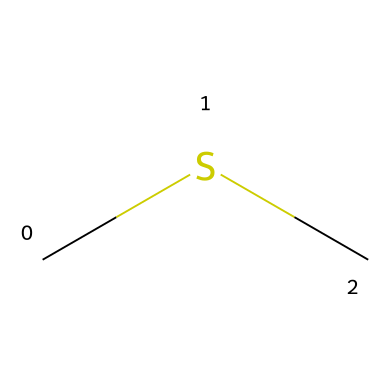What is the molecular formula of dimethyl sulfide? The SMILES representation "CSC" indicates there are two carbon (C) atoms and one sulfur (S) atom present. Thus, the molecular formula combines these elements, leading to the formula C2H6S, which also includes hydrogen atoms (H) necessary for bonding.
Answer: C2H6S How many carbon atoms are present in dimethyl sulfide? Analyzing the SMILES structure "CSC", we can see there are two distinct 'C's present in the sequence, which indicates the number of carbon atoms. Therefore, it is straightforward to count them directly from the structure.
Answer: 2 What type of chemical bond connects the carbon atoms to sulfur in dimethyl sulfide? In the structure represented by "CSC", the carbon atoms are connected through single bonds to each other and also to the sulfur atom. Sulfur typically forms single bonds with carbon in this compound type, so we deduce the bond type for clarity.
Answer: single bond How many hydrogen atoms are bonded to each carbon atom in dimethyl sulfide? Given the structure "CSC", each carbon atom must be bonded to enough hydrogen atoms to fulfill the tetravalency of carbon (which needs four bonds). Since one carbon is bonded to another carbon and sulfur, each will require three hydrogen atoms to satisfy this requirement.
Answer: 3 Is dimethyl sulfide considered a polar or nonpolar molecule? To determine polarity, we look at the symmetry of the molecule represented by "CSC". The two identical methyl groups (−CH3) result in a symmetrical distribution of charge, leading to a nonpolar characteristic overall despite the presence of sulfur.
Answer: nonpolar What is the primary role of dimethyl sulfide in ocean ecosystems? Dimethyl sulfide is primarily known for its role in the ocean as a compound produced by phytoplankton, which contributes to the scent of the ocean and is also involved in cloud formation, thus playing a significant part in marine ecology.
Answer: scent and cloud formation 